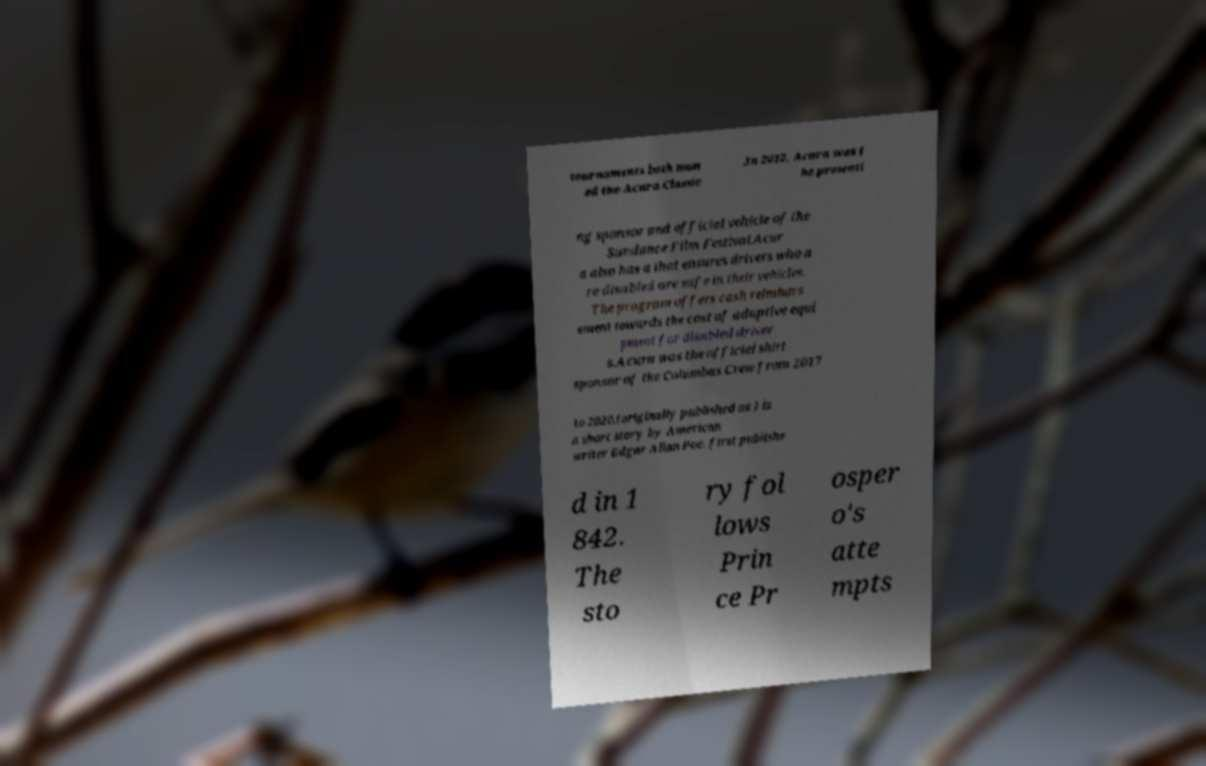Please read and relay the text visible in this image. What does it say? tournaments both nam ed the Acura Classic .In 2012, Acura was t he presenti ng sponsor and official vehicle of the Sundance Film Festival.Acur a also has a that ensures drivers who a re disabled are safe in their vehicles. The program offers cash reimburs ement towards the cost of adaptive equi pment for disabled driver s.Acura was the official shirt sponsor of the Columbus Crew from 2017 to 2020.(originally published as ) is a short story by American writer Edgar Allan Poe, first publishe d in 1 842. The sto ry fol lows Prin ce Pr osper o's atte mpts 